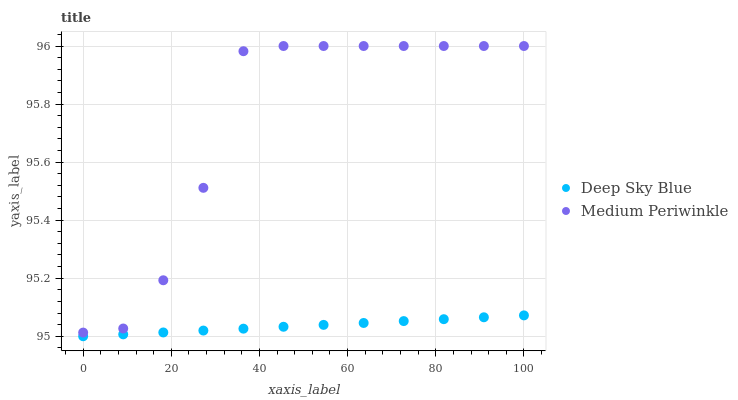Does Deep Sky Blue have the minimum area under the curve?
Answer yes or no. Yes. Does Medium Periwinkle have the maximum area under the curve?
Answer yes or no. Yes. Does Deep Sky Blue have the maximum area under the curve?
Answer yes or no. No. Is Deep Sky Blue the smoothest?
Answer yes or no. Yes. Is Medium Periwinkle the roughest?
Answer yes or no. Yes. Is Deep Sky Blue the roughest?
Answer yes or no. No. Does Deep Sky Blue have the lowest value?
Answer yes or no. Yes. Does Medium Periwinkle have the highest value?
Answer yes or no. Yes. Does Deep Sky Blue have the highest value?
Answer yes or no. No. Is Deep Sky Blue less than Medium Periwinkle?
Answer yes or no. Yes. Is Medium Periwinkle greater than Deep Sky Blue?
Answer yes or no. Yes. Does Deep Sky Blue intersect Medium Periwinkle?
Answer yes or no. No. 